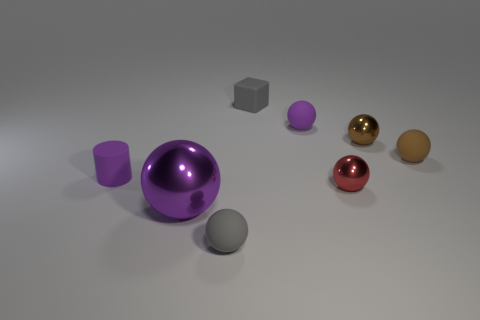Is the number of brown metallic balls on the right side of the small red ball less than the number of small things on the left side of the tiny matte block?
Offer a very short reply. Yes. There is a thing that is in front of the small brown rubber object and to the right of the small purple rubber ball; what is its shape?
Make the answer very short. Sphere. The purple thing that is the same material as the tiny red ball is what size?
Give a very brief answer. Large. Do the cylinder and the shiny thing that is to the left of the small red metal ball have the same color?
Ensure brevity in your answer.  Yes. There is a purple object that is behind the red ball and to the left of the small gray rubber cube; what is it made of?
Provide a short and direct response. Rubber. There is a matte thing that is the same color as the small matte cylinder; what size is it?
Your answer should be compact. Small. There is a tiny purple rubber object that is to the right of the rubber block; is its shape the same as the gray thing left of the gray cube?
Offer a terse response. Yes. Are there any tiny purple rubber things?
Your response must be concise. Yes. There is another tiny metallic thing that is the same shape as the tiny red shiny thing; what color is it?
Your response must be concise. Brown. What is the color of the cube that is the same size as the gray ball?
Make the answer very short. Gray. 